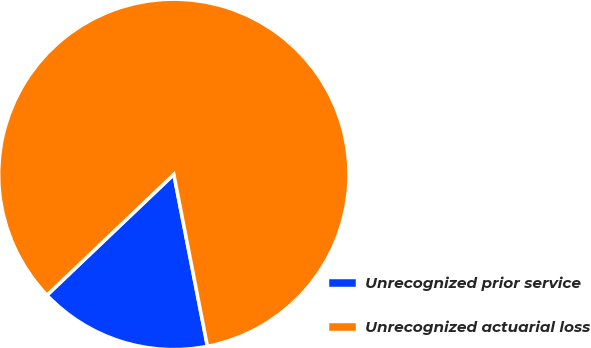<chart> <loc_0><loc_0><loc_500><loc_500><pie_chart><fcel>Unrecognized prior service<fcel>Unrecognized actuarial loss<nl><fcel>15.96%<fcel>84.04%<nl></chart> 